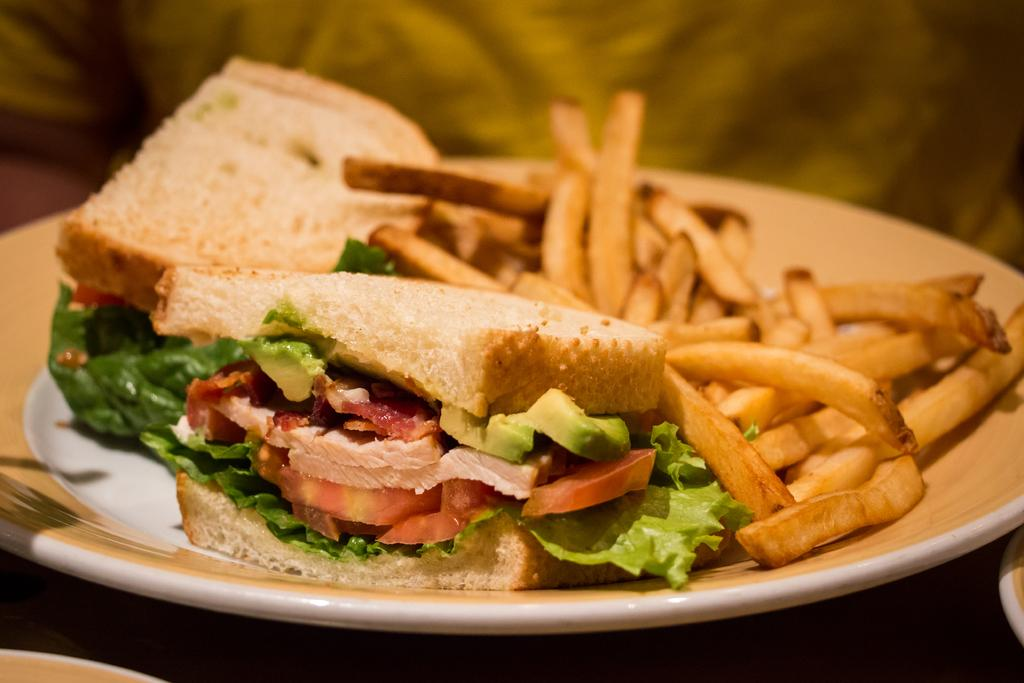What is on the plate that is visible in the image? There is a plate with food items in the image. What else can be seen in the image besides the plate with food? There are objects in the image. Can you describe the background of the image? The background of the image is blurry. How many ducks are present in the image? There are no ducks present in the image. What type of pocket can be seen in the image? There is no pocket visible in the image. 